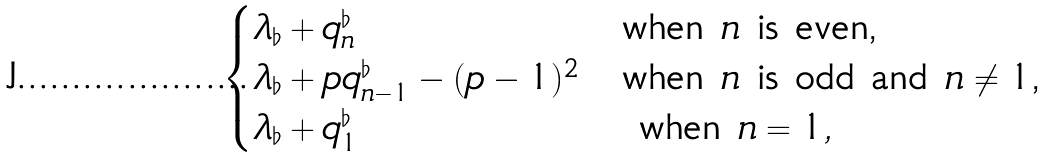Convert formula to latex. <formula><loc_0><loc_0><loc_500><loc_500>\begin{cases} \lambda _ { \flat } + q _ { n } ^ { \flat } & \text {when $n$ is even,} \\ \lambda _ { \flat } + p q _ { n - 1 } ^ { \flat } - ( p - 1 ) ^ { 2 } & \text {when $n$ is odd and $n\neq 1$,} \\ \lambda _ { \flat } + q _ { 1 } ^ { \flat } & \text { when $n=1,$} \end{cases}</formula> 